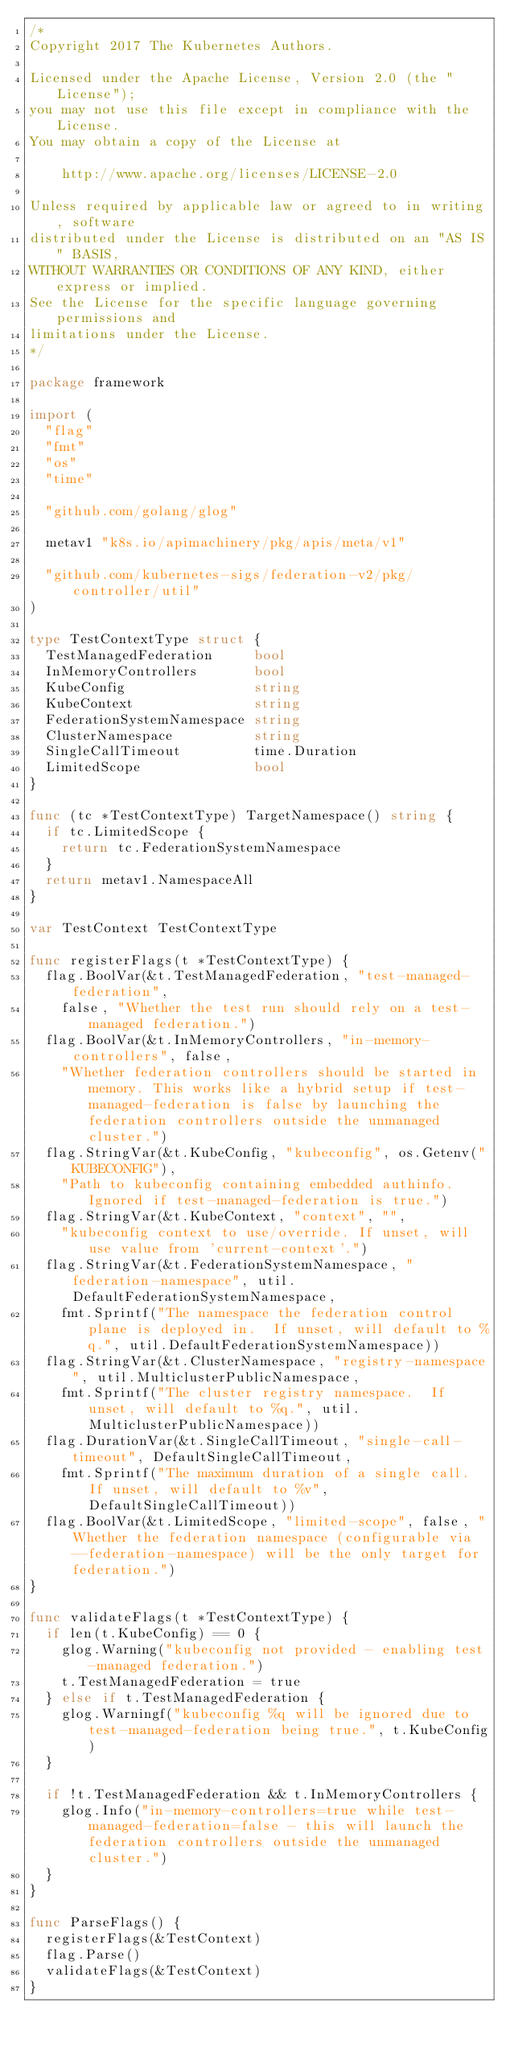<code> <loc_0><loc_0><loc_500><loc_500><_Go_>/*
Copyright 2017 The Kubernetes Authors.

Licensed under the Apache License, Version 2.0 (the "License");
you may not use this file except in compliance with the License.
You may obtain a copy of the License at

    http://www.apache.org/licenses/LICENSE-2.0

Unless required by applicable law or agreed to in writing, software
distributed under the License is distributed on an "AS IS" BASIS,
WITHOUT WARRANTIES OR CONDITIONS OF ANY KIND, either express or implied.
See the License for the specific language governing permissions and
limitations under the License.
*/

package framework

import (
	"flag"
	"fmt"
	"os"
	"time"

	"github.com/golang/glog"

	metav1 "k8s.io/apimachinery/pkg/apis/meta/v1"

	"github.com/kubernetes-sigs/federation-v2/pkg/controller/util"
)

type TestContextType struct {
	TestManagedFederation     bool
	InMemoryControllers       bool
	KubeConfig                string
	KubeContext               string
	FederationSystemNamespace string
	ClusterNamespace          string
	SingleCallTimeout         time.Duration
	LimitedScope              bool
}

func (tc *TestContextType) TargetNamespace() string {
	if tc.LimitedScope {
		return tc.FederationSystemNamespace
	}
	return metav1.NamespaceAll
}

var TestContext TestContextType

func registerFlags(t *TestContextType) {
	flag.BoolVar(&t.TestManagedFederation, "test-managed-federation",
		false, "Whether the test run should rely on a test-managed federation.")
	flag.BoolVar(&t.InMemoryControllers, "in-memory-controllers", false,
		"Whether federation controllers should be started in memory. This works like a hybrid setup if test-managed-federation is false by launching the federation controllers outside the unmanaged cluster.")
	flag.StringVar(&t.KubeConfig, "kubeconfig", os.Getenv("KUBECONFIG"),
		"Path to kubeconfig containing embedded authinfo.  Ignored if test-managed-federation is true.")
	flag.StringVar(&t.KubeContext, "context", "",
		"kubeconfig context to use/override. If unset, will use value from 'current-context'.")
	flag.StringVar(&t.FederationSystemNamespace, "federation-namespace", util.DefaultFederationSystemNamespace,
		fmt.Sprintf("The namespace the federation control plane is deployed in.  If unset, will default to %q.", util.DefaultFederationSystemNamespace))
	flag.StringVar(&t.ClusterNamespace, "registry-namespace", util.MulticlusterPublicNamespace,
		fmt.Sprintf("The cluster registry namespace.  If unset, will default to %q.", util.MulticlusterPublicNamespace))
	flag.DurationVar(&t.SingleCallTimeout, "single-call-timeout", DefaultSingleCallTimeout,
		fmt.Sprintf("The maximum duration of a single call.  If unset, will default to %v", DefaultSingleCallTimeout))
	flag.BoolVar(&t.LimitedScope, "limited-scope", false, "Whether the federation namespace (configurable via --federation-namespace) will be the only target for federation.")
}

func validateFlags(t *TestContextType) {
	if len(t.KubeConfig) == 0 {
		glog.Warning("kubeconfig not provided - enabling test-managed federation.")
		t.TestManagedFederation = true
	} else if t.TestManagedFederation {
		glog.Warningf("kubeconfig %q will be ignored due to test-managed-federation being true.", t.KubeConfig)
	}

	if !t.TestManagedFederation && t.InMemoryControllers {
		glog.Info("in-memory-controllers=true while test-managed-federation=false - this will launch the federation controllers outside the unmanaged cluster.")
	}
}

func ParseFlags() {
	registerFlags(&TestContext)
	flag.Parse()
	validateFlags(&TestContext)
}
</code> 